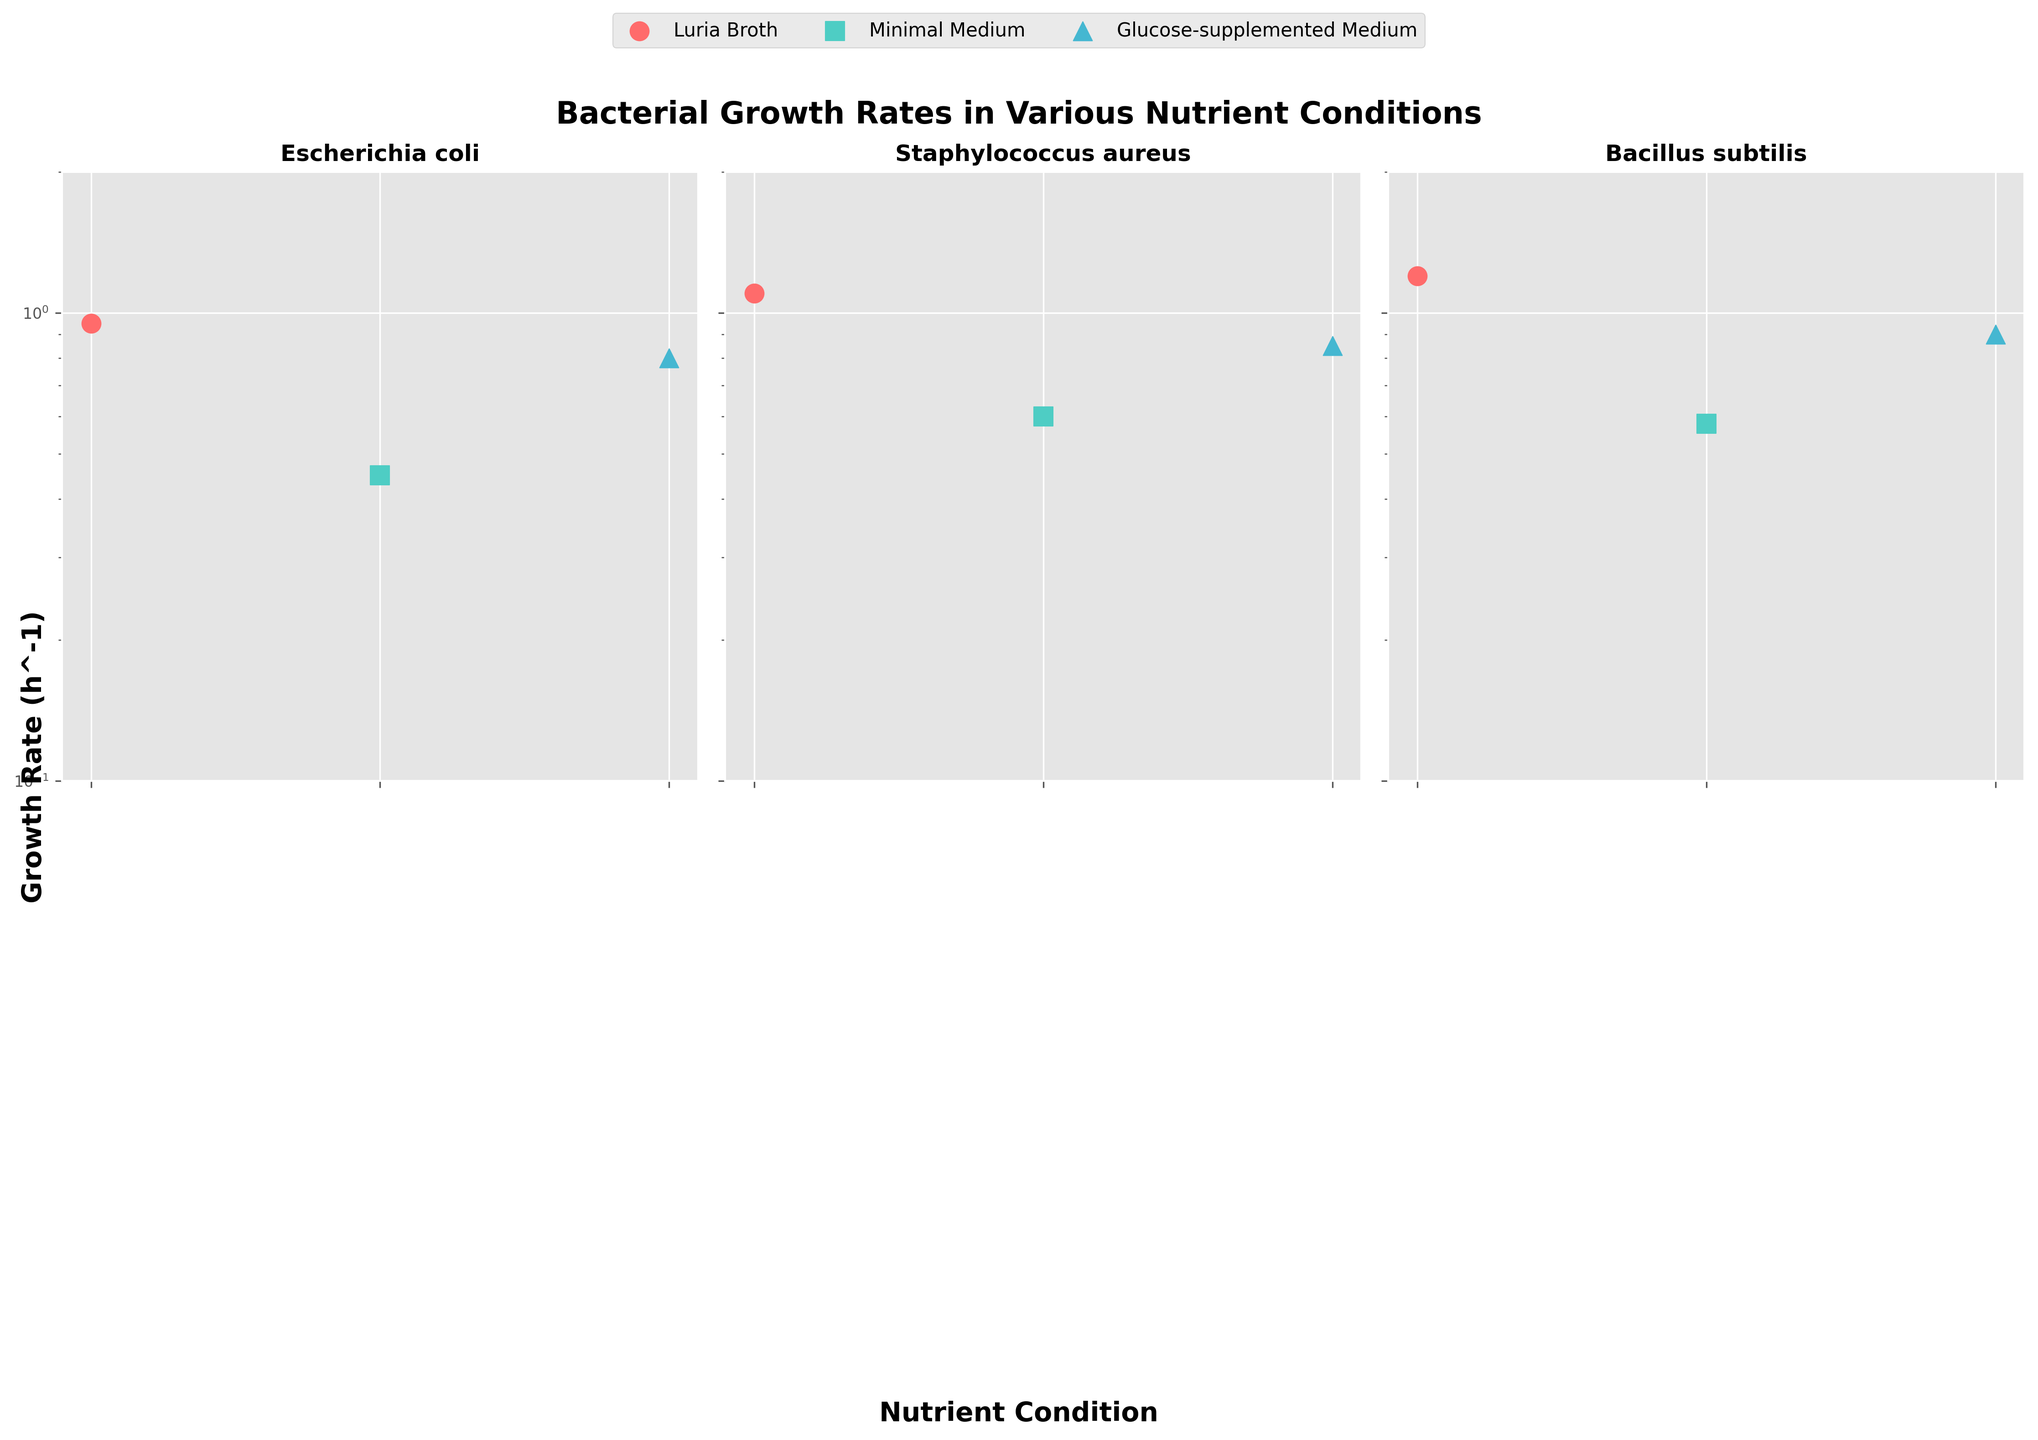What is the title of the figure? The title is displayed at the top of the figure and provides an overview of the data being visualized.
Answer: Bacterial Growth Rates in Various Nutrient Conditions What is the range of the y-axis? By observing the y-axis, it is clear that it ranges from 0.1 to 2, using a logarithmic scale.
Answer: 0.1 to 2 Which bacterium has the highest growth rate in Luria Broth? Look at the Luria Broth condition for each bacterium subplot and identify the highest growth rate. Bacillus subtilis has the highest growth rate.
Answer: Bacillus subtilis What is the median growth rate of Escherichia coli across all nutrient conditions? Identify growth rates of Escherichia coli for all conditions (0.95, 0.45, 0.8) and find the median value. Sort: 0.45, 0.8, 0.95. Median is 0.8.
Answer: 0.8 Which bacterium shows the smallest difference in growth rates between different nutrient conditions? Calculate the range (max growth rate - min growth rate) for each bacterium. The bacterium with the smallest range is Pseudomonas aeruginosa with range 0.47 (0.87 - 0.4).
Answer: Pseudomonas aeruginosa For which nutrient condition do we observe the highest variation in growth rates among all bacteria? Note the growth rates for each nutrient condition, then calculate the variance. Luria Broth condition shows the highest variation as Bacillus subtilis (1.2) is much higher compared to Pseudomonas aeruginosa (0.87).
Answer: Luria Broth What is the combined growth rate of Staphylococcus aureus and Salmonella enterica in the Minimal Medium condition? Sum the growth rates of Staphylococcus aureus (0.60) and Salmonella enterica (0.50) in Minimal Medium. 0.60 + 0.50 = 1.1
Answer: 1.1 Which nutrient condition consistently results in the highest growth rates across different bacteria? Compare the growth rates for each nutrient condition across all bacteria. Luria Broth condition consistently shows high growth rates.
Answer: Luria Broth Are there any bacteria that exhibit a higher growth rate in Minimal Medium compared to Glucose-supplemented Medium? Compare the growth rates of each bacterium in Minimal Medium against Glucose-supplemented Medium. None show higher growth in Minimal Medium.
Answer: No How does the growth rate of Escherichia coli in Glucose-supplemented Medium compare to that in Luria Broth? Compare Escherichia coli growth rates in Glucose-supplemented Medium (0.80) and Luria Broth (0.95). 0.80 is less than 0.95.
Answer: It is lower 